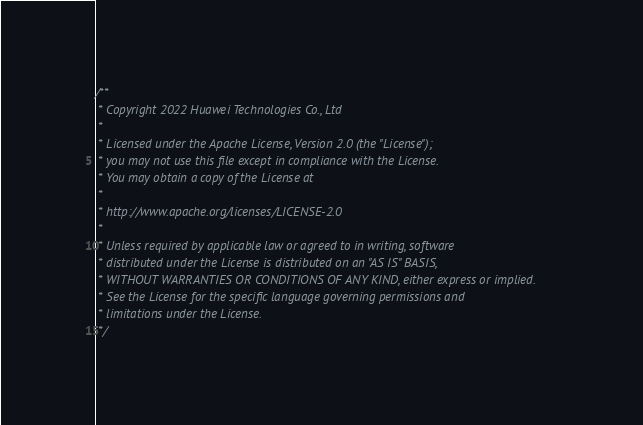Convert code to text. <code><loc_0><loc_0><loc_500><loc_500><_Cuda_>/**
 * Copyright 2022 Huawei Technologies Co., Ltd
 *
 * Licensed under the Apache License, Version 2.0 (the "License");
 * you may not use this file except in compliance with the License.
 * You may obtain a copy of the License at
 *
 * http://www.apache.org/licenses/LICENSE-2.0
 *
 * Unless required by applicable law or agreed to in writing, software
 * distributed under the License is distributed on an "AS IS" BASIS,
 * WITHOUT WARRANTIES OR CONDITIONS OF ANY KIND, either express or implied.
 * See the License for the specific language governing permissions and
 * limitations under the License.
 */
</code> 